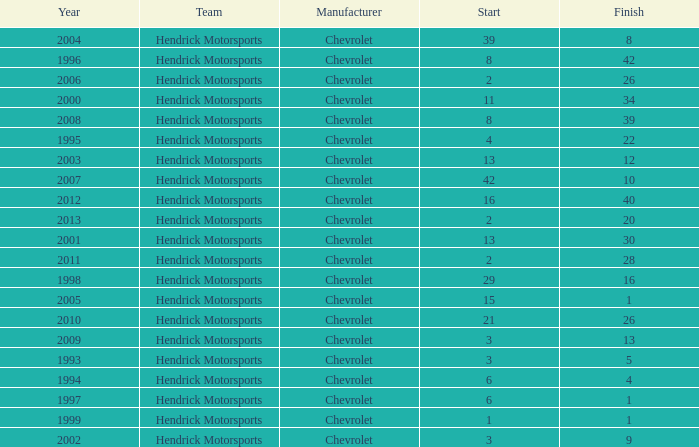Which team had a start of 8 in years under 2008? Hendrick Motorsports. 